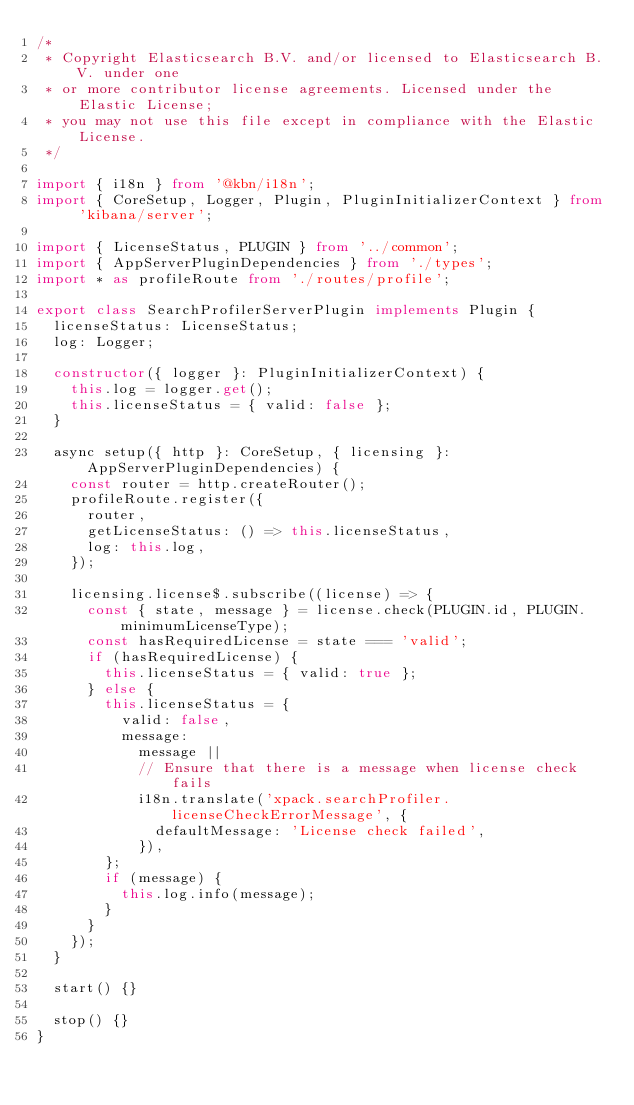Convert code to text. <code><loc_0><loc_0><loc_500><loc_500><_TypeScript_>/*
 * Copyright Elasticsearch B.V. and/or licensed to Elasticsearch B.V. under one
 * or more contributor license agreements. Licensed under the Elastic License;
 * you may not use this file except in compliance with the Elastic License.
 */

import { i18n } from '@kbn/i18n';
import { CoreSetup, Logger, Plugin, PluginInitializerContext } from 'kibana/server';

import { LicenseStatus, PLUGIN } from '../common';
import { AppServerPluginDependencies } from './types';
import * as profileRoute from './routes/profile';

export class SearchProfilerServerPlugin implements Plugin {
  licenseStatus: LicenseStatus;
  log: Logger;

  constructor({ logger }: PluginInitializerContext) {
    this.log = logger.get();
    this.licenseStatus = { valid: false };
  }

  async setup({ http }: CoreSetup, { licensing }: AppServerPluginDependencies) {
    const router = http.createRouter();
    profileRoute.register({
      router,
      getLicenseStatus: () => this.licenseStatus,
      log: this.log,
    });

    licensing.license$.subscribe((license) => {
      const { state, message } = license.check(PLUGIN.id, PLUGIN.minimumLicenseType);
      const hasRequiredLicense = state === 'valid';
      if (hasRequiredLicense) {
        this.licenseStatus = { valid: true };
      } else {
        this.licenseStatus = {
          valid: false,
          message:
            message ||
            // Ensure that there is a message when license check fails
            i18n.translate('xpack.searchProfiler.licenseCheckErrorMessage', {
              defaultMessage: 'License check failed',
            }),
        };
        if (message) {
          this.log.info(message);
        }
      }
    });
  }

  start() {}

  stop() {}
}
</code> 